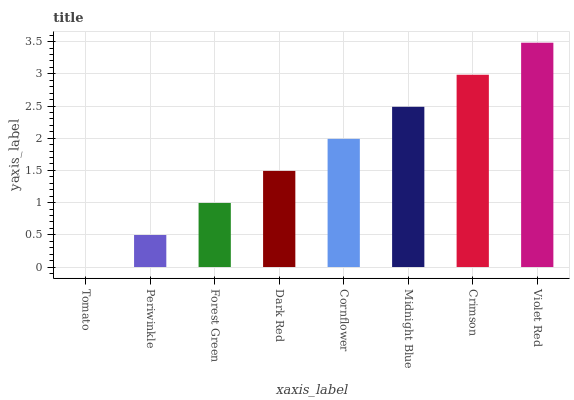Is Periwinkle the minimum?
Answer yes or no. No. Is Periwinkle the maximum?
Answer yes or no. No. Is Periwinkle greater than Tomato?
Answer yes or no. Yes. Is Tomato less than Periwinkle?
Answer yes or no. Yes. Is Tomato greater than Periwinkle?
Answer yes or no. No. Is Periwinkle less than Tomato?
Answer yes or no. No. Is Cornflower the high median?
Answer yes or no. Yes. Is Dark Red the low median?
Answer yes or no. Yes. Is Tomato the high median?
Answer yes or no. No. Is Midnight Blue the low median?
Answer yes or no. No. 